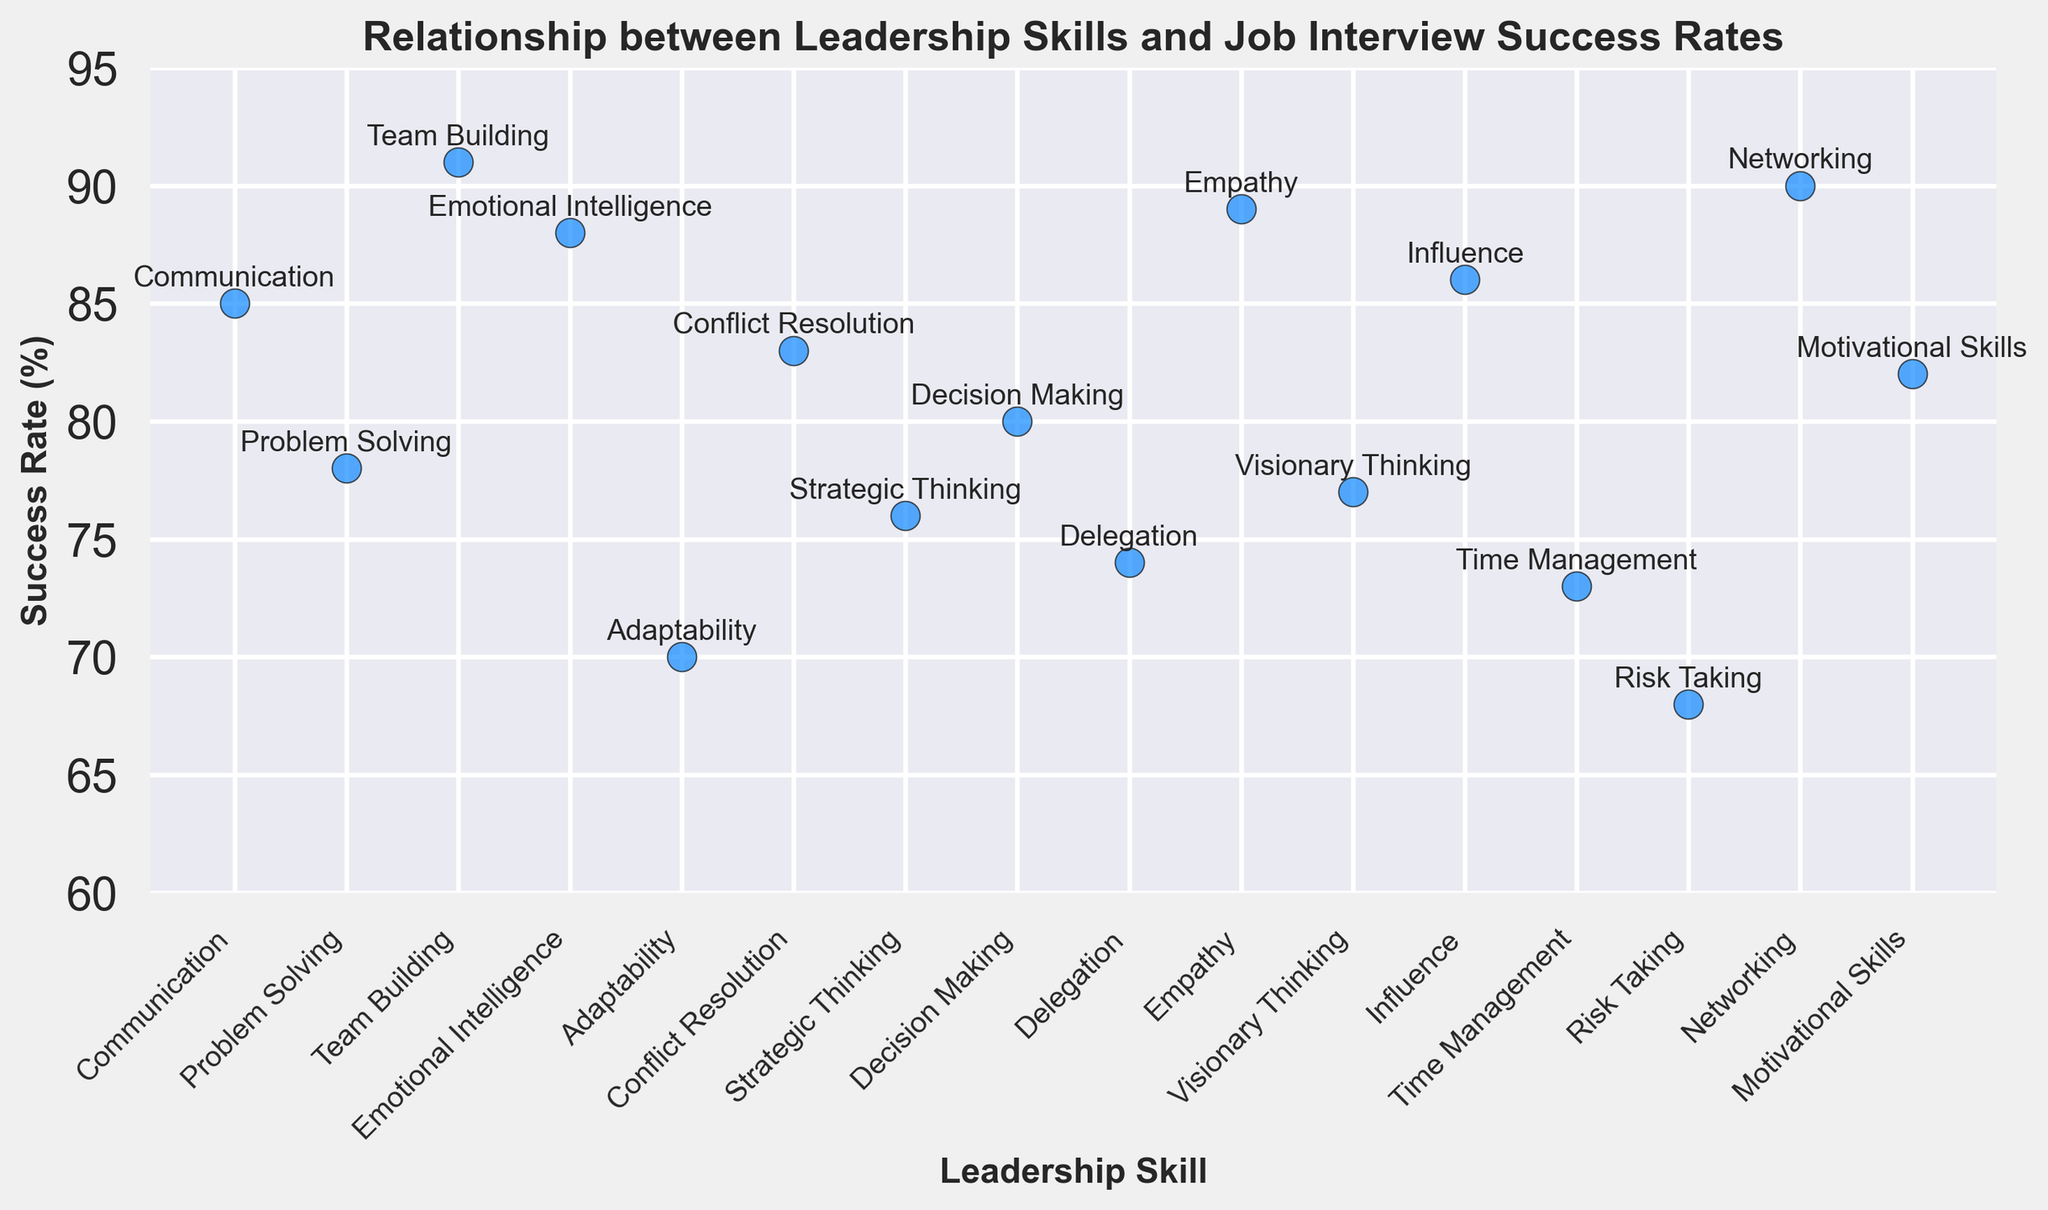Which leadership skill has the highest success rate? By examining the highest point of the scatter plot and identifying the corresponding skill label, we can see which leadership skill has the highest success rate.
Answer: Team Building Which leadership skill has the lowest success rate? By examining the lowest point of the scatter plot and identifying the corresponding skill label, we can see which leadership skill has the lowest success rate.
Answer: Risk Taking What is the difference in success rates between the highest and lowest leadership skills? Identify the highest success rate (Team Building at 91%) and the lowest success rate (Risk Taking at 68%). Calculate the difference as 91 - 68.
Answer: 23% Which two leadership skills have similar success rates around 80%? Look for points around 80% and identify their corresponding skill labels. The skills around 80% are Decision Making (80%) and Motivational Skills (82%).
Answer: Decision Making and Motivational Skills What is the average success rate of communication, empathy, and networking skills? Identify the success rates for Communication (85%), Empathy (89%), and Networking (90%). Calculate the average as (85 + 89 + 90) / 3.
Answer: 88% Which leadership skill slightly edges out Problem Solving in success rate? Find Problem Solving with a success rate of 78% and identify the nearest higher success rate. Emotional Intelligence has a success rate of 88%, which is higher but not slightly. Look for others and find Visionary Thinking at 77%, but it’s lower. The slightly higher one than 78% is Strategic Thinking with a success rate of 76%, thus slight edge could be wrongly interpreted, another nearby nearly close would be Decision Making at (80%).
Answer: Decision Making Are there more leadership skills with success rates above 80% or below 80%? Count the number of skills with success rates above 80% and below 80%. There are 9 skills above 80% (Communication, Team Building, Emotional Intelligence, Conflict Resolution, Decision Making, Empathy, Visionary Thinking, Networking, Motivational Skills) and 7 below 80% (Problem Solving, Adaptability, Strategic Thinking, Delegation, Risk Taking).
Answer: Above 80% Does Adaptability have a higher or lower success rate than Time Management? Compare the success rates of Adaptability (70%) and Time Management (73%). Adaptability is lower.
Answer: Lower Are any two leadership skills positioned closely together visually on the scatter plot, indicating similar success rates? Examine the scatter plot for points that are visually close. Communication (85%) and Influence (86%) are visually close to each other.
Answer: Communication and Influence 